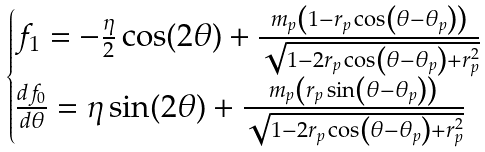<formula> <loc_0><loc_0><loc_500><loc_500>\begin{cases} f _ { 1 } = - \frac { \eta } { 2 } \cos ( 2 \theta ) + \frac { m _ { p } \left ( 1 - r _ { p } \cos \left ( \theta - \theta _ { p } \right ) \right ) } { \sqrt { 1 - 2 r _ { p } \cos \left ( \theta - \theta _ { p } \right ) + r _ { p } ^ { 2 } } } \\ \frac { d f _ { 0 } } { d \theta } = \eta \sin ( 2 \theta ) + \frac { m _ { p } \left ( r _ { p } \sin \left ( \theta - \theta _ { p } \right ) \right ) } { \sqrt { 1 - 2 r _ { p } \cos \left ( \theta - \theta _ { p } \right ) + r _ { p } ^ { 2 } } } \\ \end{cases}</formula> 